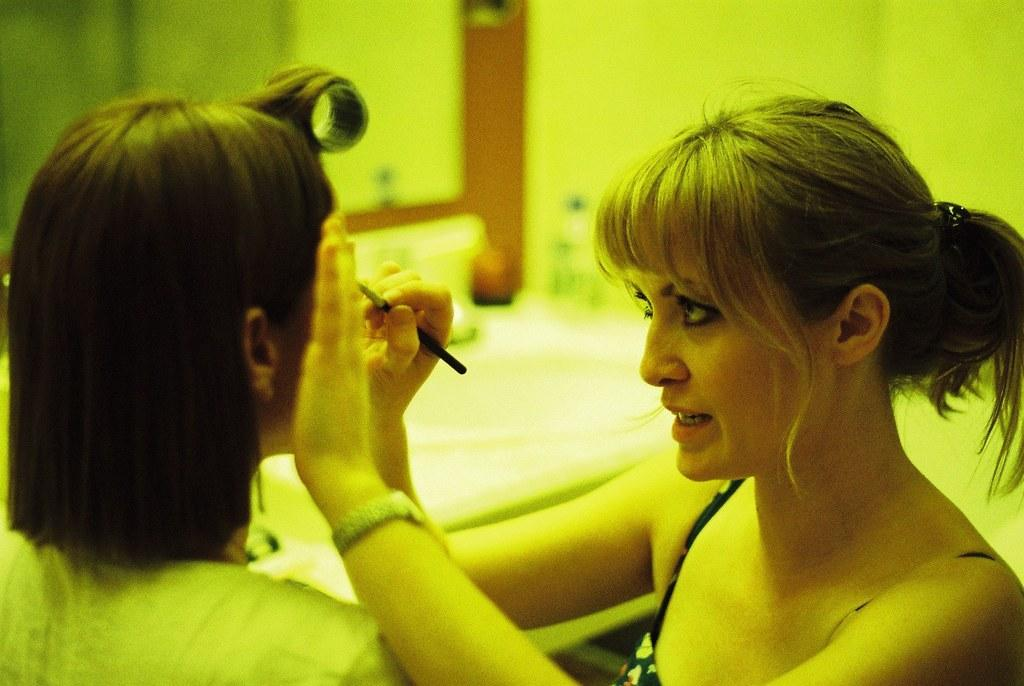Who is the main subject in the image? There is a woman in the image. What is the woman doing in the image? The woman is looking at the left side and touching another person. Can you describe any objects or features in the background of the image? There appears to be a mirror at the top of the image. What type of machine is visible in the image? There is no machine present in the image. How many trains can be seen in the image? There are no trains visible in the image. 